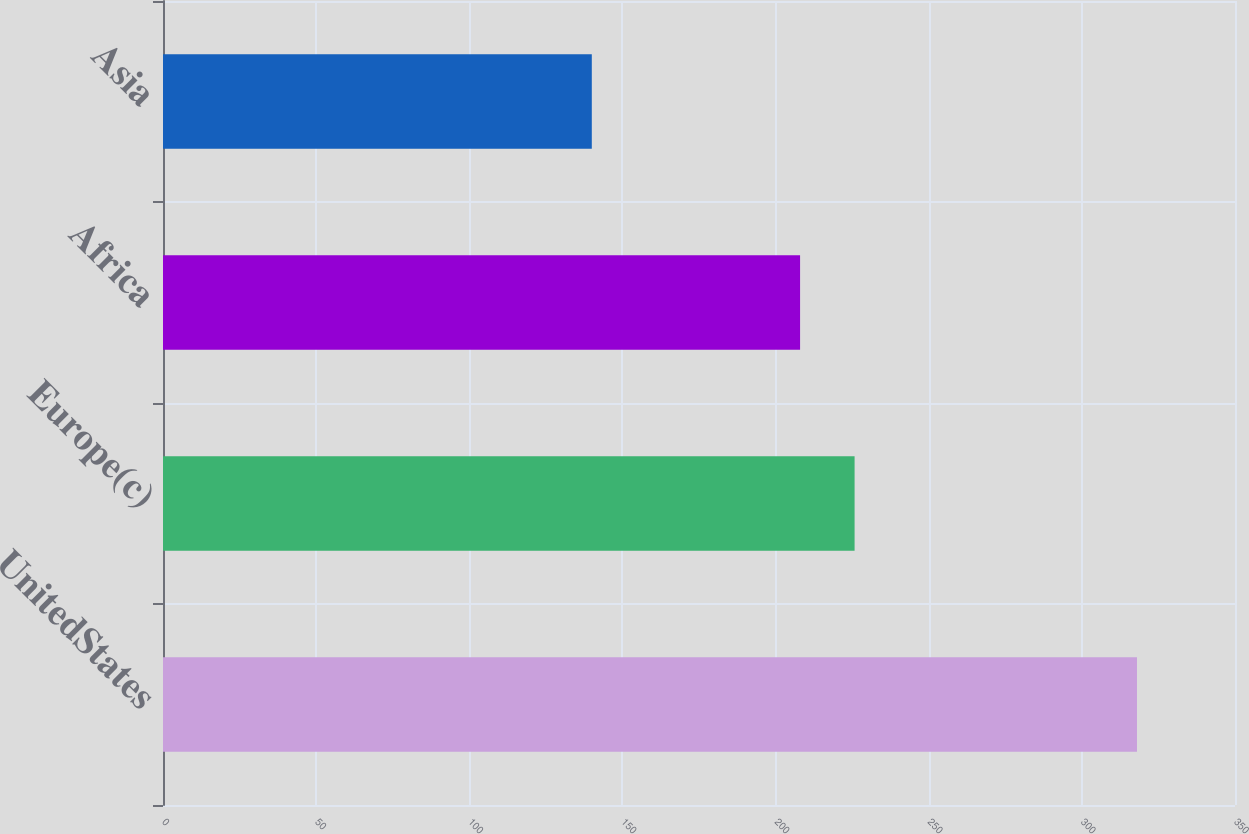<chart> <loc_0><loc_0><loc_500><loc_500><bar_chart><fcel>UnitedStates<fcel>Europe(c)<fcel>Africa<fcel>Asia<nl><fcel>318<fcel>225.8<fcel>208<fcel>140<nl></chart> 